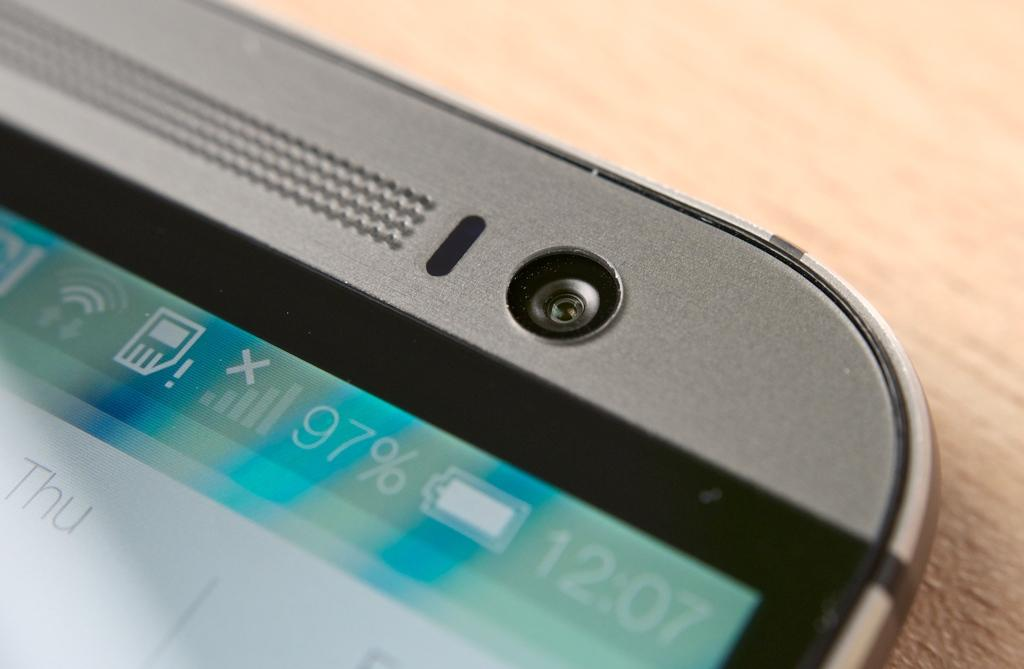<image>
Present a compact description of the photo's key features. a close up of a phone screen reading 12:07 